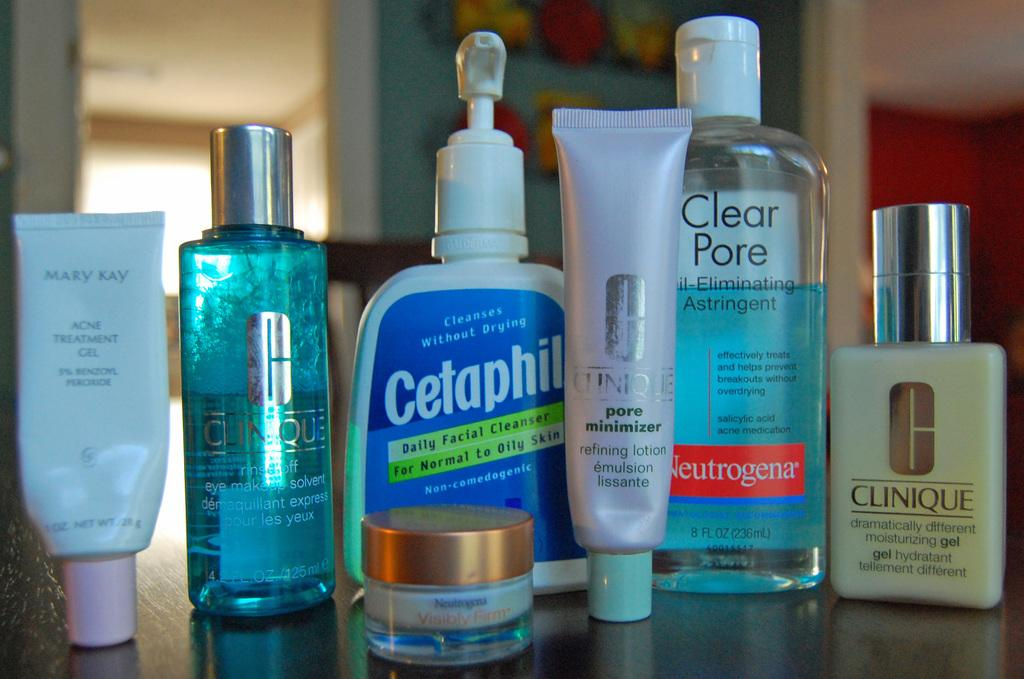<image>
Relay a brief, clear account of the picture shown. A bottle of Cetaphil facial cleanser is lined up along with a Neutrogena product and other skincare items. 